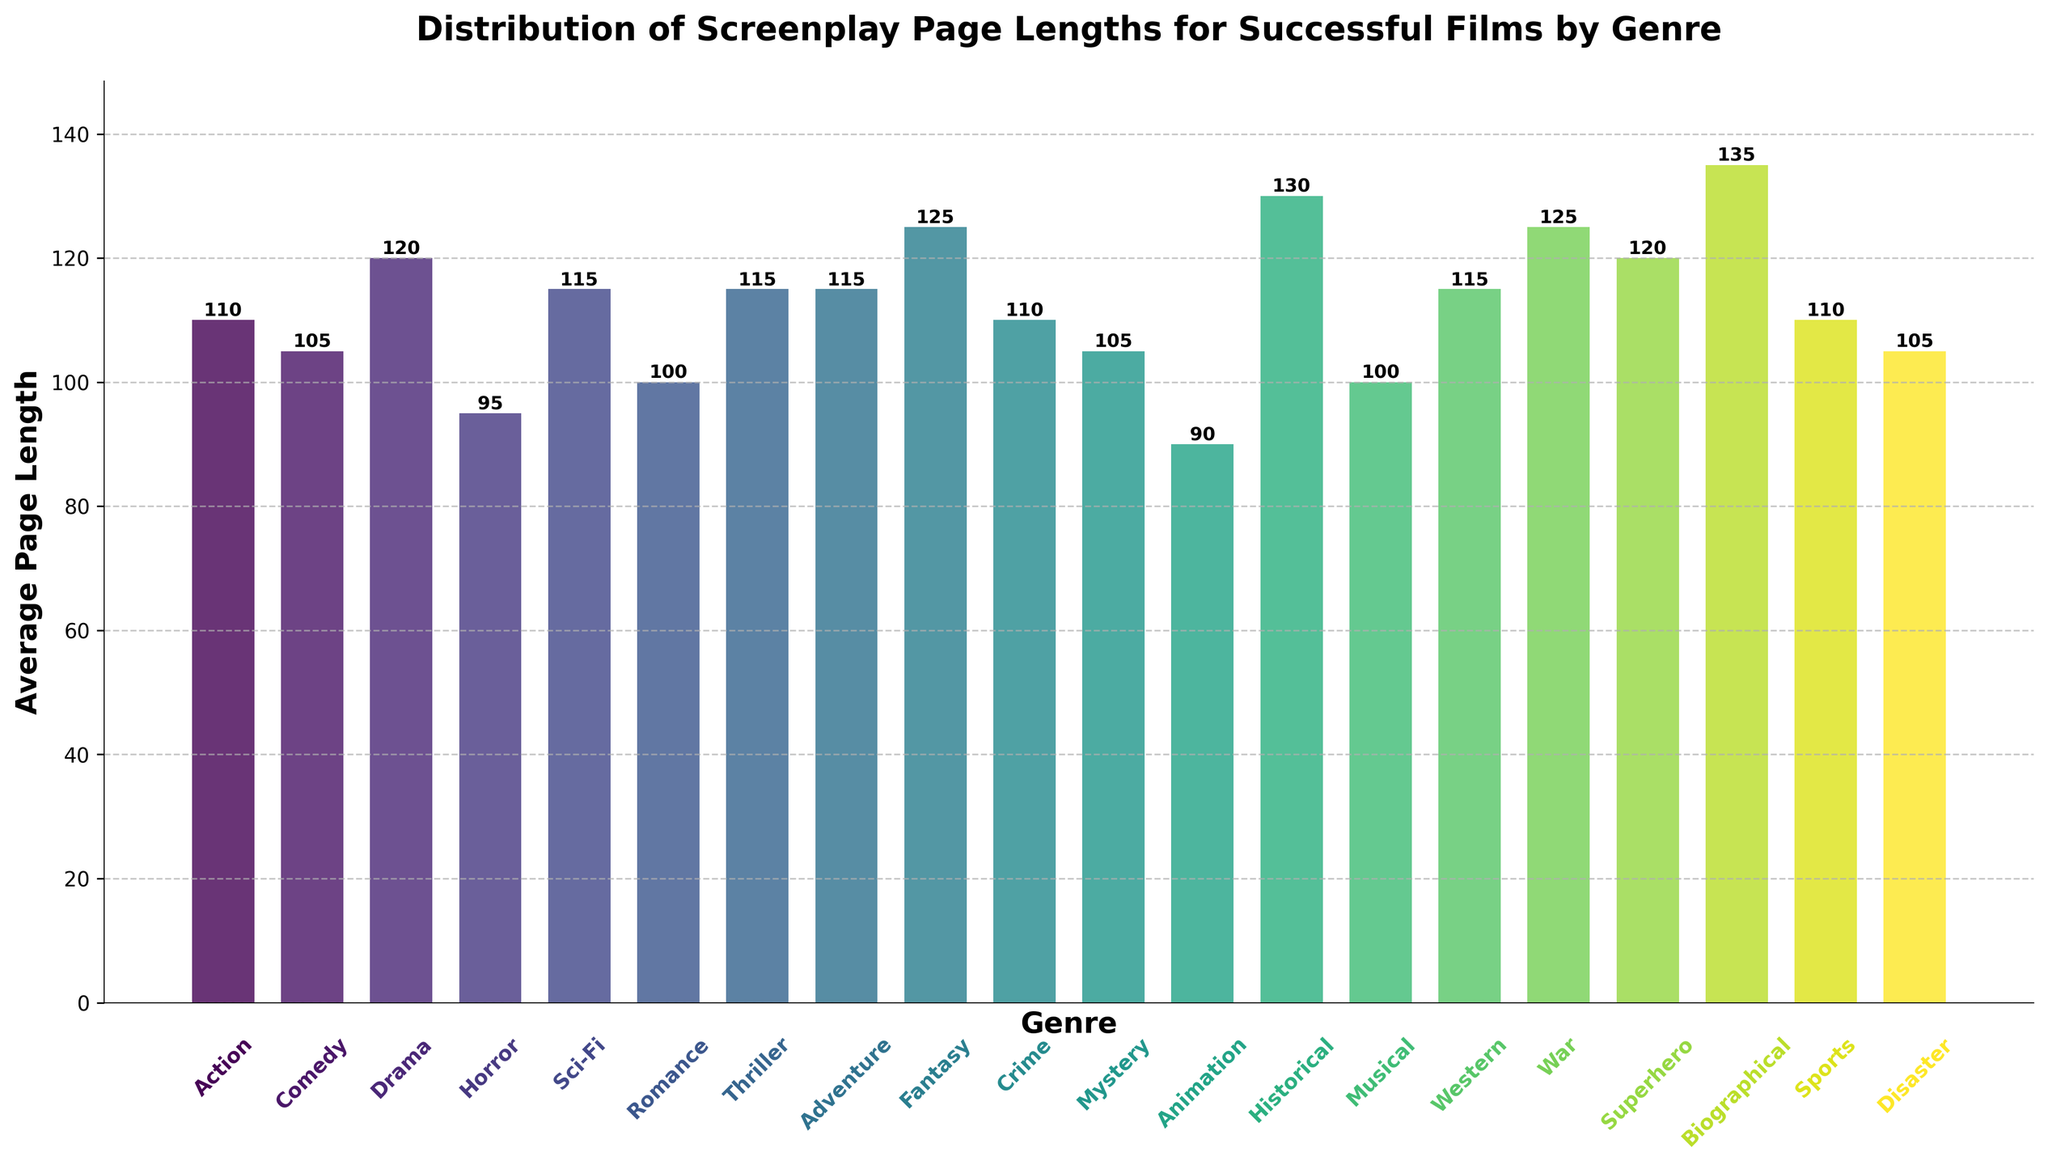what's the shortest average page length by genre? The figure shows multiple genres with their respective average page lengths. Identify the bar with the shortest height to find the shortest average page length. The shortest bar corresponds to the "Animation" genre with a page length of 90.
Answer: 90 which genre has the highest average page length? The figure displays various bars representing different genres. Locate the tallest bar. The tallest bar corresponds to the "Biographical" genre with an average page length of 135.
Answer: Biographical what's the difference in average page lengths between Horror and Drama? Locate the bars for both "Horror" and "Drama". The heights represent their average page lengths: "Horror" is 95, and "Drama" is 120. Subtract the average of "Horror" from "Drama": 120 - 95 = 25.
Answer: 25 how many genres have an average page length of 115 or more? Count the number of bars that meet or exceed a height representing a page length of 115. The genres "Sci-Fi", "Thriller", "Adventure", "Fantasy", "Western", "War", and "Superhero" meet this condition.
Answer: 7 which genres have an average page length equal to Comedy? Locate the bar corresponding to "Comedy" with an average page length of 105. Identify other bars with the same height. The "Mystery" and "Disaster" genres also have an average page length of 105.
Answer: Mystery, Disaster what's the average page length for Drama, Sci-Fi, and War combined? Locate the bars for "Drama" (120), "Sci-Fi" (115), and "War" (125). Sum their page lengths: 120 + 115 + 125 = 360. Divide by 3 (the number of genres): 360 / 3 = 120.
Answer: 120 which genre is visually represented with the shortest bar? Observe the heights of all the bars and identify the smallest one. The shortest bar represents the "Animation" genre with an average page length of 90.
Answer: Animation what's the range of average page lengths across all genres? Find the difference between the highest and lowest average page lengths in the chart. The highest is "Biographical" (135) and the lowest is "Animation" (90). Calculate the range: 135 - 90 = 45.
Answer: 45 compare the average page lengths of Action and Superhero genres. Which genre has a longer average page length? Locate the bars for "Action" (110) and "Superhero" (120). By comparing their heights, determine that "Superhero" has a longer average page length.
Answer: Superhero 